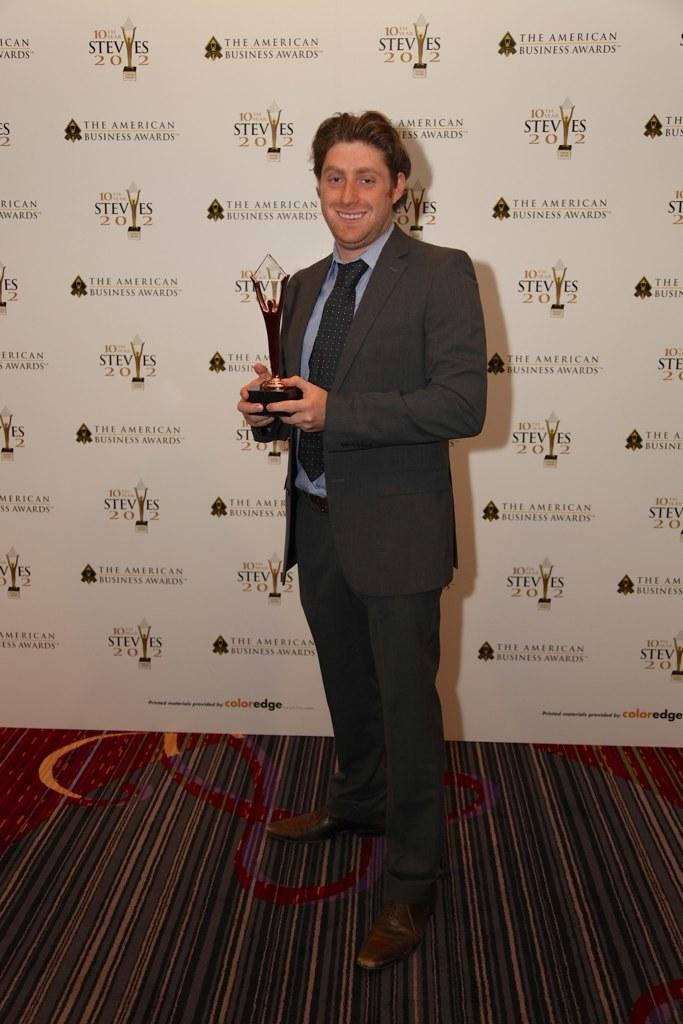What is the man in the image doing? The man is standing in the image and smiling. What is the man holding in the image? The man is holding a trophy in the image. What type of clothing is the man wearing in the image? The man is wearing a suit, a tie, a shirt, trousers, and shoes in the image. What can be inferred about the setting of the image? The image appears to be a hoarding. How many pages are visible in the image? There are no pages present in the image; it is a hoarding featuring a man holding a trophy. What is the amount of back pain the man is experiencing in the image? There is no indication of back pain in the image, as the man is standing and smiling. 